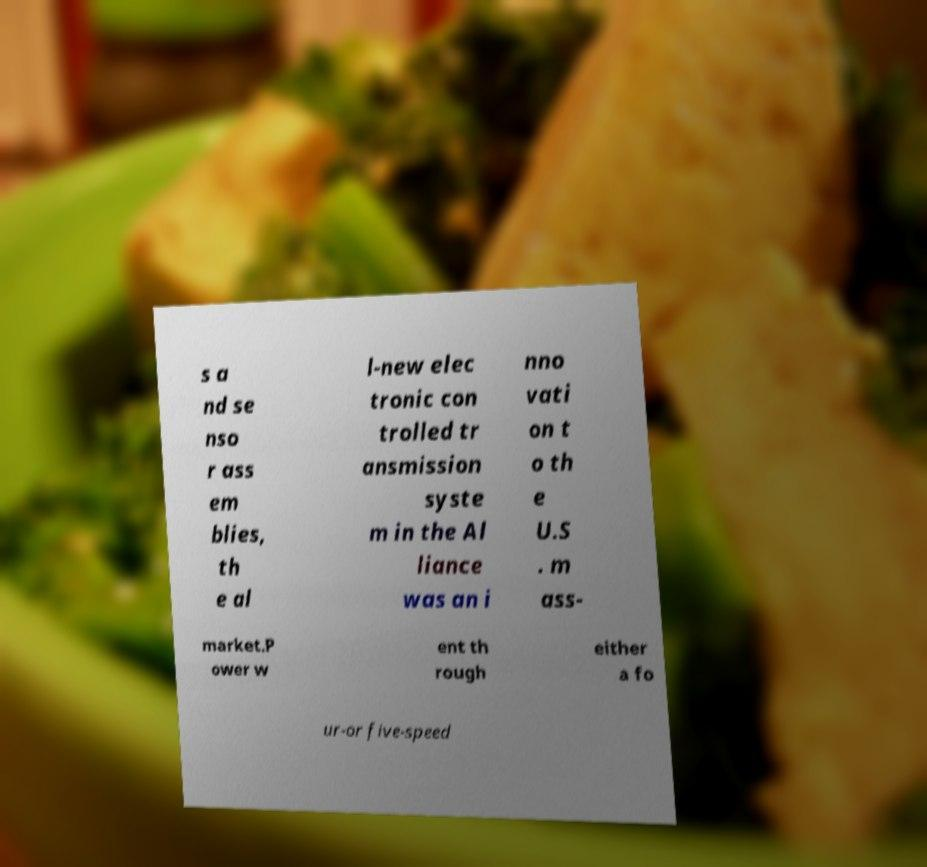There's text embedded in this image that I need extracted. Can you transcribe it verbatim? s a nd se nso r ass em blies, th e al l-new elec tronic con trolled tr ansmission syste m in the Al liance was an i nno vati on t o th e U.S . m ass- market.P ower w ent th rough either a fo ur-or five-speed 